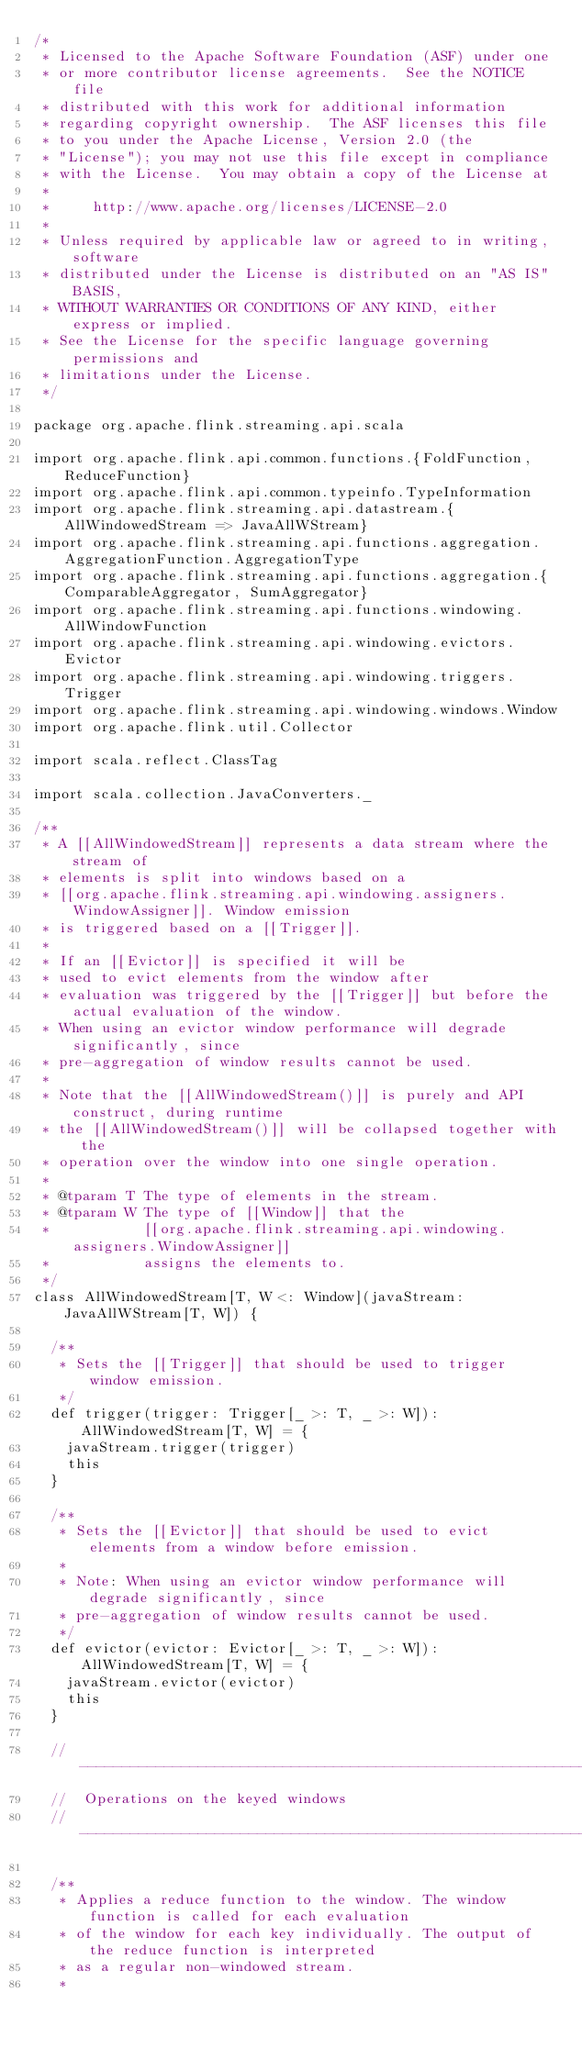Convert code to text. <code><loc_0><loc_0><loc_500><loc_500><_Scala_>/*
 * Licensed to the Apache Software Foundation (ASF) under one
 * or more contributor license agreements.  See the NOTICE file
 * distributed with this work for additional information
 * regarding copyright ownership.  The ASF licenses this file
 * to you under the Apache License, Version 2.0 (the
 * "License"); you may not use this file except in compliance
 * with the License.  You may obtain a copy of the License at
 *
 *     http://www.apache.org/licenses/LICENSE-2.0
 *
 * Unless required by applicable law or agreed to in writing, software
 * distributed under the License is distributed on an "AS IS" BASIS,
 * WITHOUT WARRANTIES OR CONDITIONS OF ANY KIND, either express or implied.
 * See the License for the specific language governing permissions and
 * limitations under the License.
 */

package org.apache.flink.streaming.api.scala

import org.apache.flink.api.common.functions.{FoldFunction, ReduceFunction}
import org.apache.flink.api.common.typeinfo.TypeInformation
import org.apache.flink.streaming.api.datastream.{AllWindowedStream => JavaAllWStream}
import org.apache.flink.streaming.api.functions.aggregation.AggregationFunction.AggregationType
import org.apache.flink.streaming.api.functions.aggregation.{ComparableAggregator, SumAggregator}
import org.apache.flink.streaming.api.functions.windowing.AllWindowFunction
import org.apache.flink.streaming.api.windowing.evictors.Evictor
import org.apache.flink.streaming.api.windowing.triggers.Trigger
import org.apache.flink.streaming.api.windowing.windows.Window
import org.apache.flink.util.Collector

import scala.reflect.ClassTag

import scala.collection.JavaConverters._

/**
 * A [[AllWindowedStream]] represents a data stream where the stream of
 * elements is split into windows based on a
 * [[org.apache.flink.streaming.api.windowing.assigners.WindowAssigner]]. Window emission
 * is triggered based on a [[Trigger]].
 *
 * If an [[Evictor]] is specified it will be
 * used to evict elements from the window after
 * evaluation was triggered by the [[Trigger]] but before the actual evaluation of the window.
 * When using an evictor window performance will degrade significantly, since
 * pre-aggregation of window results cannot be used.
 *
 * Note that the [[AllWindowedStream()]] is purely and API construct, during runtime
 * the [[AllWindowedStream()]] will be collapsed together with the
 * operation over the window into one single operation.
 *
 * @tparam T The type of elements in the stream.
 * @tparam W The type of [[Window]] that the
 *           [[org.apache.flink.streaming.api.windowing.assigners.WindowAssigner]]
 *           assigns the elements to.
 */
class AllWindowedStream[T, W <: Window](javaStream: JavaAllWStream[T, W]) {

  /**
   * Sets the [[Trigger]] that should be used to trigger window emission.
   */
  def trigger(trigger: Trigger[_ >: T, _ >: W]): AllWindowedStream[T, W] = {
    javaStream.trigger(trigger)
    this
  }

  /**
   * Sets the [[Evictor]] that should be used to evict elements from a window before emission.
   *
   * Note: When using an evictor window performance will degrade significantly, since
   * pre-aggregation of window results cannot be used.
   */
  def evictor(evictor: Evictor[_ >: T, _ >: W]): AllWindowedStream[T, W] = {
    javaStream.evictor(evictor)
    this
  }

  // ------------------------------------------------------------------------
  //  Operations on the keyed windows
  // ------------------------------------------------------------------------

  /**
   * Applies a reduce function to the window. The window function is called for each evaluation
   * of the window for each key individually. The output of the reduce function is interpreted
   * as a regular non-windowed stream.
   *</code> 